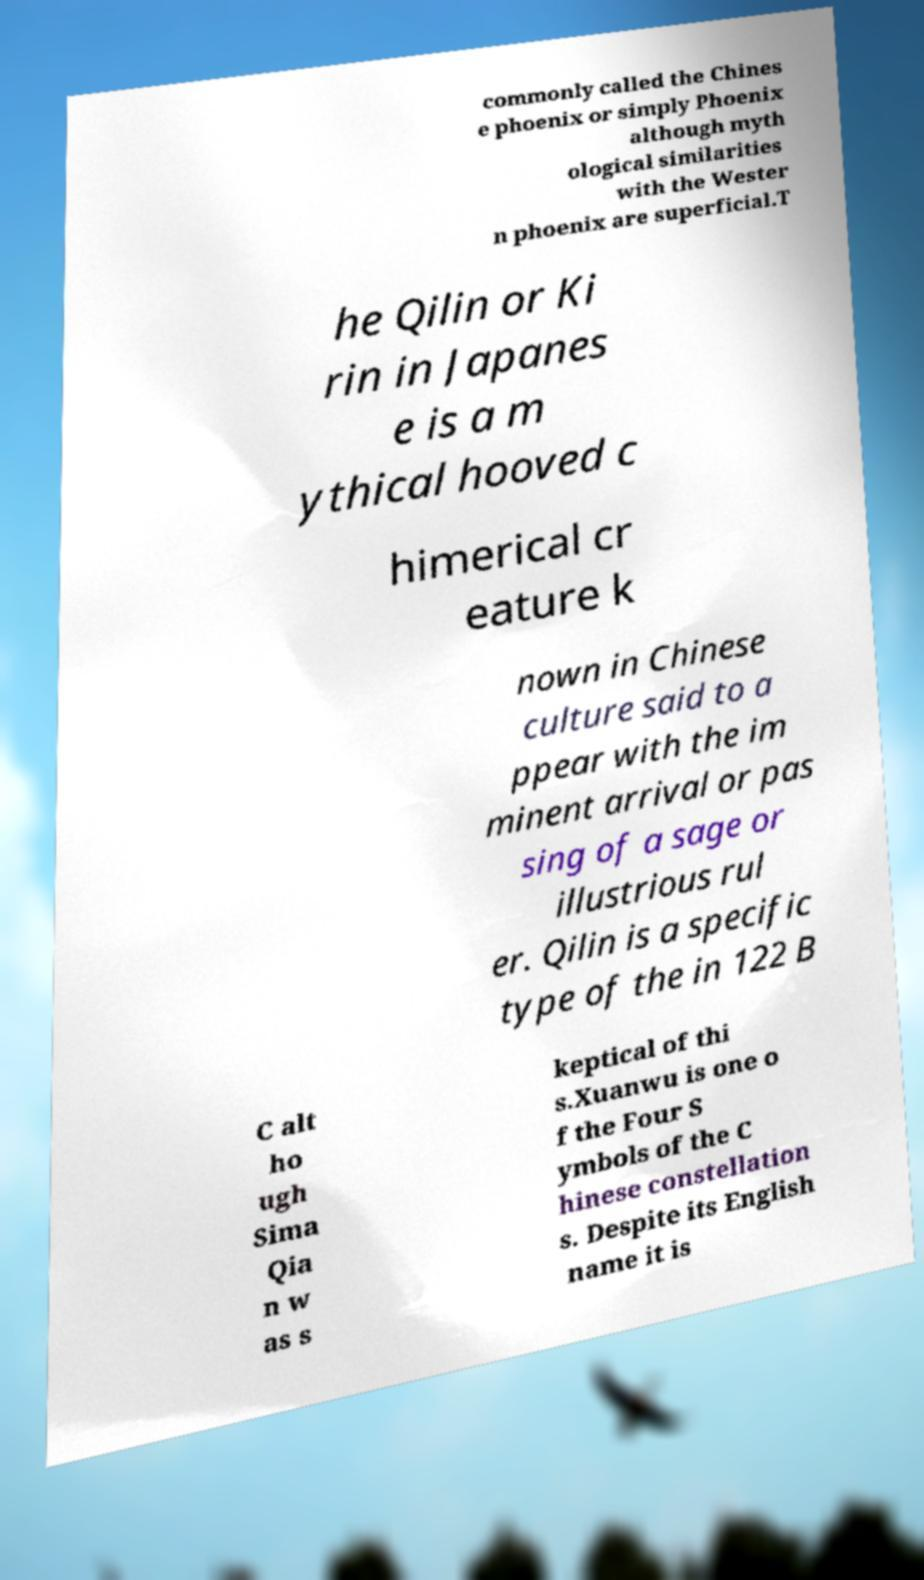Please read and relay the text visible in this image. What does it say? commonly called the Chines e phoenix or simply Phoenix although myth ological similarities with the Wester n phoenix are superficial.T he Qilin or Ki rin in Japanes e is a m ythical hooved c himerical cr eature k nown in Chinese culture said to a ppear with the im minent arrival or pas sing of a sage or illustrious rul er. Qilin is a specific type of the in 122 B C alt ho ugh Sima Qia n w as s keptical of thi s.Xuanwu is one o f the Four S ymbols of the C hinese constellation s. Despite its English name it is 